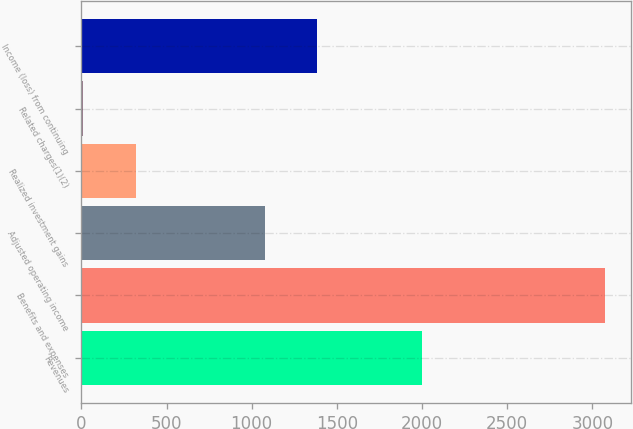<chart> <loc_0><loc_0><loc_500><loc_500><bar_chart><fcel>Revenues<fcel>Benefits and expenses<fcel>Adjusted operating income<fcel>Realized investment gains<fcel>Related charges(1)(2)<fcel>Income (loss) from continuing<nl><fcel>1999<fcel>3076<fcel>1077<fcel>318.4<fcel>12<fcel>1383.4<nl></chart> 